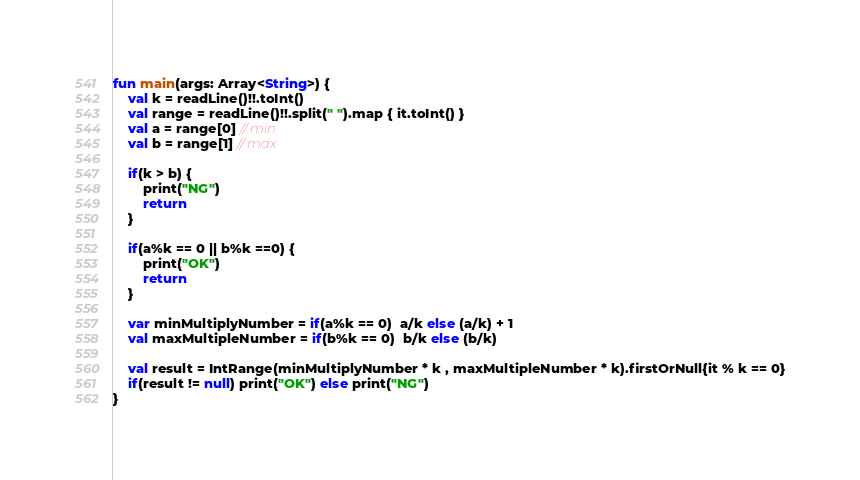Convert code to text. <code><loc_0><loc_0><loc_500><loc_500><_Kotlin_>fun main(args: Array<String>) {
    val k = readLine()!!.toInt()
    val range = readLine()!!.split(" ").map { it.toInt() }
    val a = range[0] // min
    val b = range[1] // max

    if(k > b) {
        print("NG")
        return
    }

    if(a%k == 0 || b%k ==0) {
        print("OK")
        return
    }

    var minMultiplyNumber = if(a%k == 0)  a/k else (a/k) + 1
    val maxMultipleNumber = if(b%k == 0)  b/k else (b/k)

    val result = IntRange(minMultiplyNumber * k , maxMultipleNumber * k).firstOrNull{it % k == 0}
    if(result != null) print("OK") else print("NG")
}
</code> 